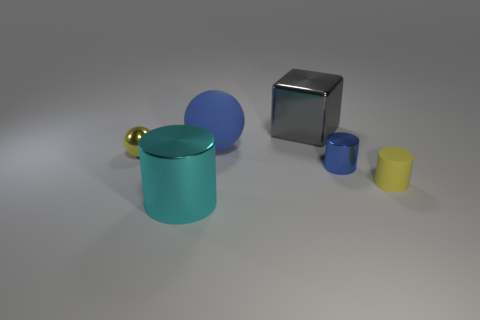Subtract all purple cylinders. Subtract all yellow cubes. How many cylinders are left? 3 Add 3 big red matte blocks. How many objects exist? 9 Subtract all balls. How many objects are left? 4 Add 3 big red cubes. How many big red cubes exist? 3 Subtract 0 blue blocks. How many objects are left? 6 Subtract all small yellow matte cylinders. Subtract all tiny metal cylinders. How many objects are left? 4 Add 2 blue shiny cylinders. How many blue shiny cylinders are left? 3 